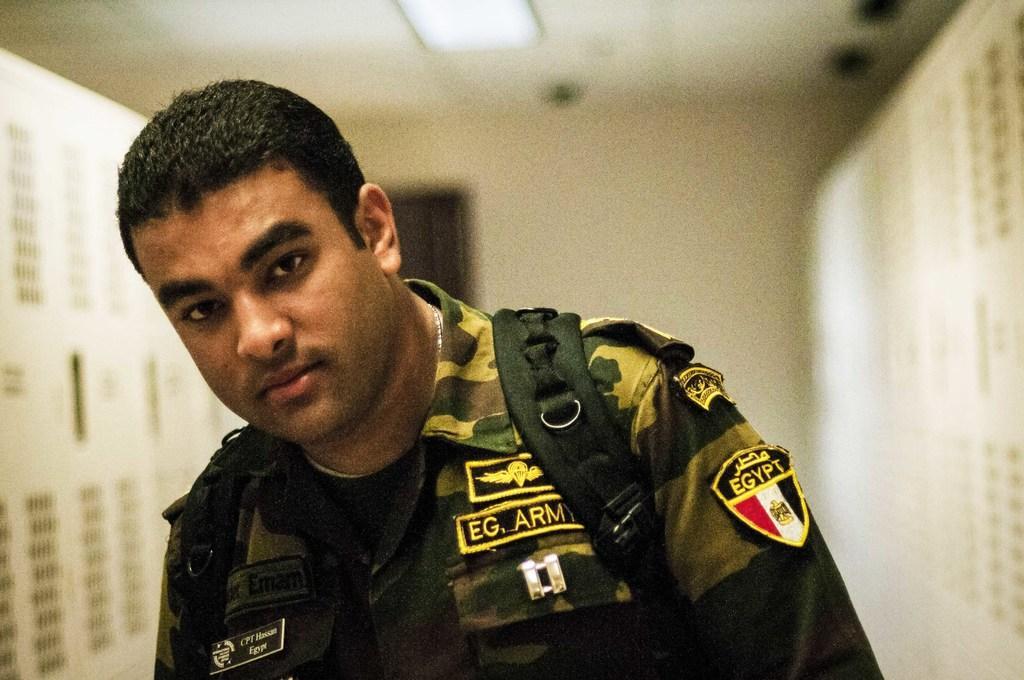In one or two sentences, can you explain what this image depicts? In this picture we can see a person. There is a light on top. Background is blurry. 